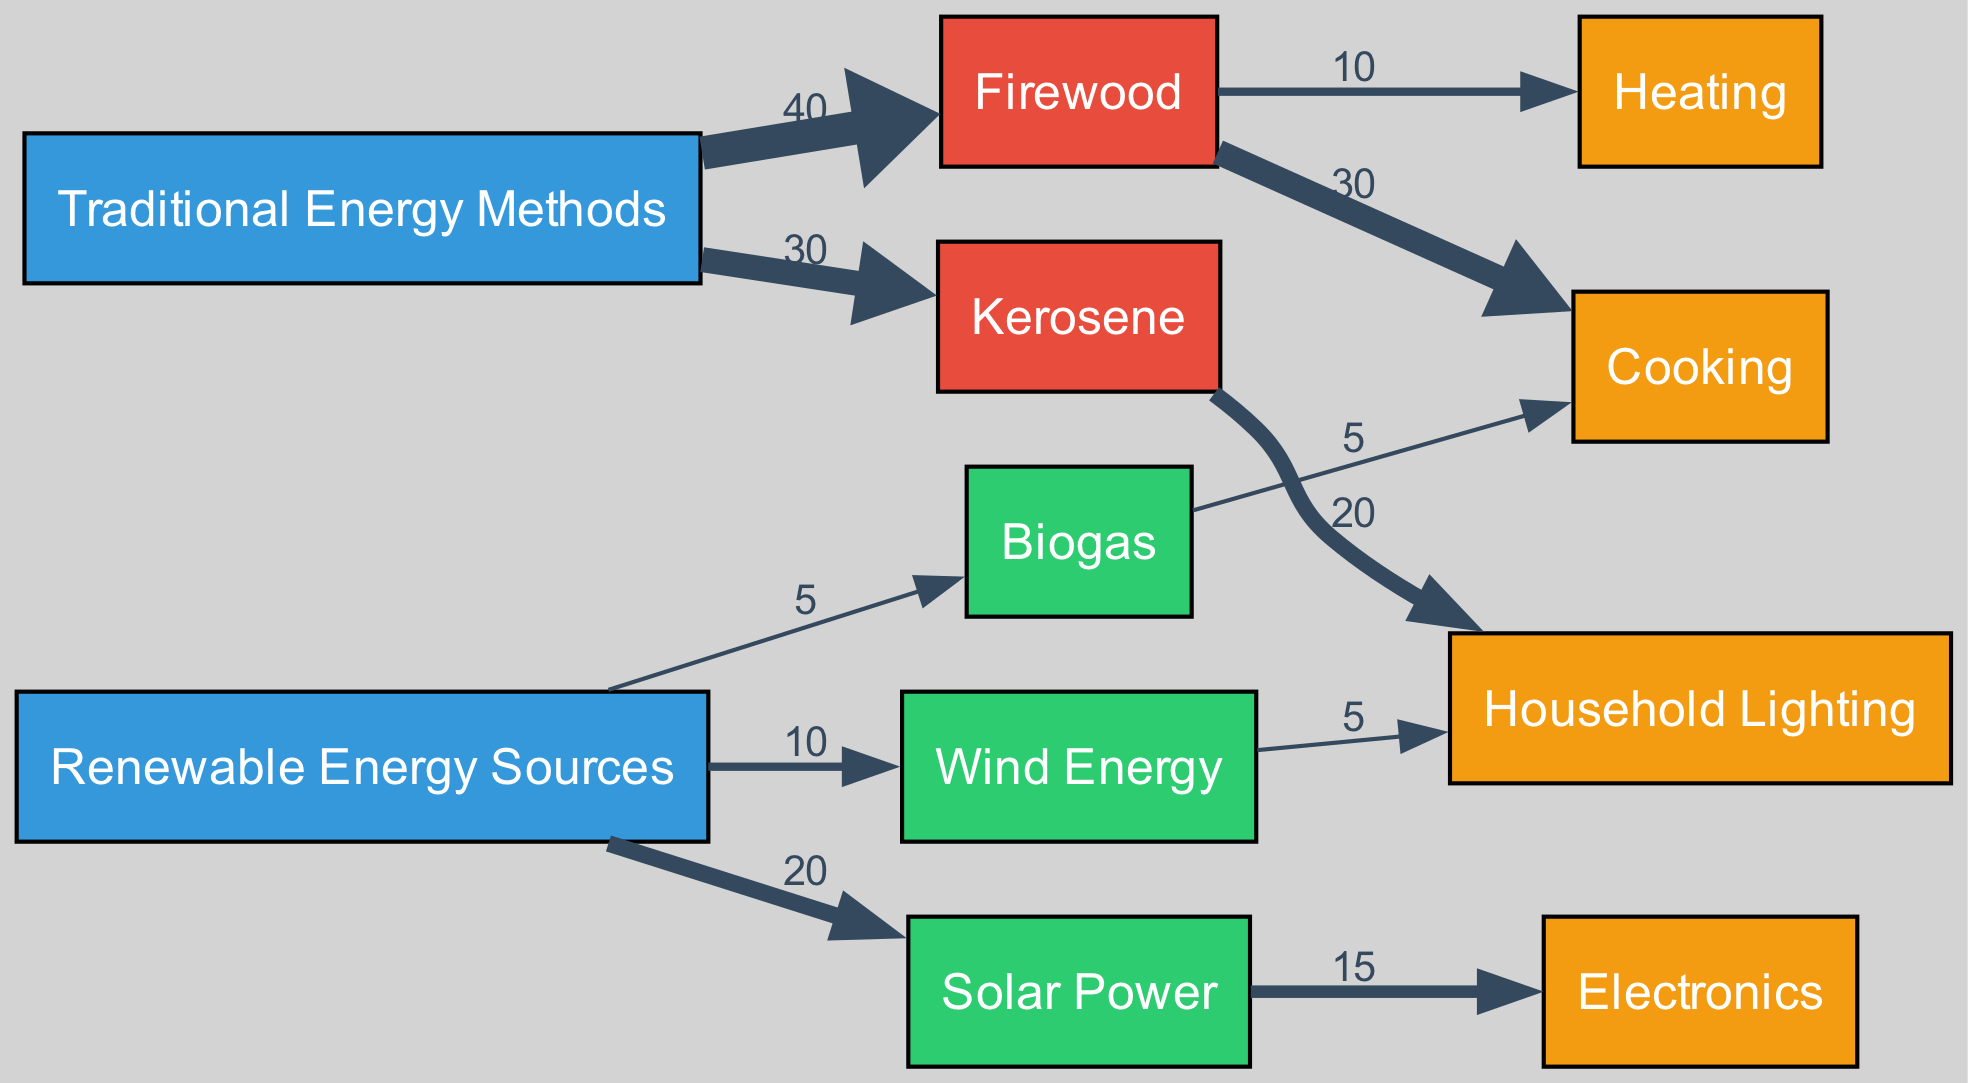What is the total energy consumption from traditional methods? To find the total energy consumption from traditional methods, add the values of Firewood (40) and Kerosene (30). Thus, 40 + 30 equals 70.
Answer: 70 What energy source is used the least in Micronesian households? The energy sources are Biogas (5), Wind Energy (10), Solar Power (20), Firewood (40), and Kerosene (30). The smallest value is for Biogas, which has a value of 5.
Answer: Biogas Which traditional energy method is used most for cooking? Cooking is linked to Firewood with a value of 30. No other traditional energy method shows a higher value for cooking.
Answer: Firewood What is the value of energy used for household lighting from kerosene? The link from Kerosene to Household Lighting shows a value of 20. Therefore, the energy used for household lighting from Kerosene is 20.
Answer: 20 How much total renewable energy is used in electronics? The total renewable energy used for electronics comes from Solar Power (15). There are no other links from renewable sources to electronics, so the total is 15.
Answer: 15 Which type of energy contributes most to cooking? Firewood contributes 30 to cooking, while Biogas contributes only 5. Comparing these, Firewood is the dominant contributor at 30.
Answer: Firewood What percentage of traditional energy is used for cooking? The total traditional energy consumption is 70. Since cooking uses 30 from Firewood, the percentage is (30/70) * 100, which equals approximately 42.86%.
Answer: 42.86% What is the total flow from renewable energy sources to household lighting? Renewable sources contribute from Solar Power (0 to household lighting) and Wind Energy (5 to household lighting). The total flow is thus Wind Energy's 5.
Answer: 5 Which renewable energy source has the highest value? Looking at the values for renewable sources: Solar Power (20), Wind Energy (10), Biogas (5), Solar Power is the highest with a value of 20.
Answer: Solar Power 